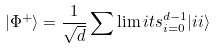<formula> <loc_0><loc_0><loc_500><loc_500>| \Phi ^ { + } \rangle = \frac { 1 } { \sqrt { d } } \sum \lim i t s _ { i = 0 } ^ { d - 1 } { | i i \rangle }</formula> 